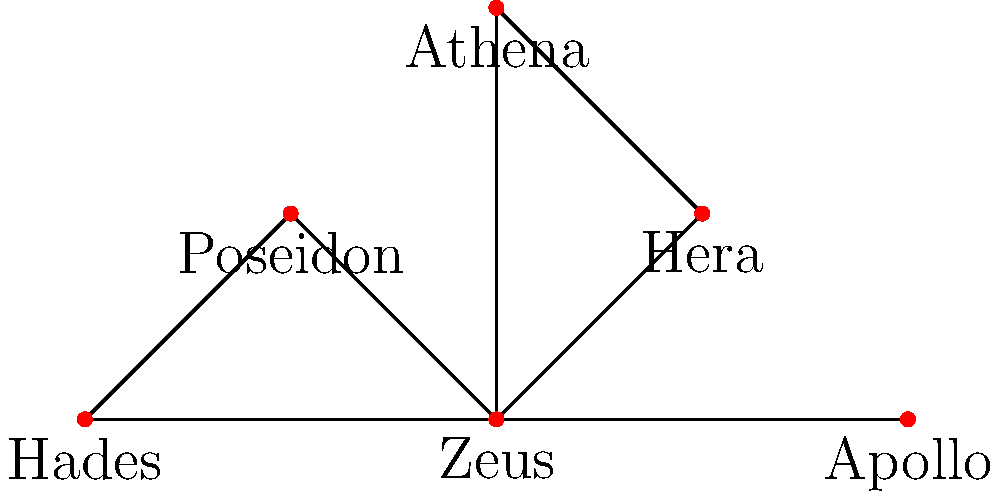In the network graph representing relationships between Greek mythological characters, which character has the highest degree centrality (i.e., the most direct connections to other characters)? To determine the character with the highest degree centrality, we need to count the number of direct connections (edges) each character has to other characters in the network graph. Let's analyze each character:

1. Zeus: Connected to Hera, Poseidon, Athena, Hades, and Apollo (5 connections)
2. Hera: Connected to Zeus and Athena (2 connections)
3. Poseidon: Connected to Zeus (1 connection)
4. Athena: Connected to Zeus and Hera (2 connections)
5. Hades: Connected to Zeus and Poseidon (2 connections)
6. Apollo: Connected to Zeus (1 connection)

By counting the number of edges connected to each vertex (character), we can see that Zeus has the highest number of connections with 5 direct links to other characters in the network.

This high degree centrality for Zeus aligns with his mythological role as the king of the gods, having numerous relationships and interactions with other deities in Greek mythology. This network structure could be used in storytelling to emphasize Zeus's central role in various myths and his influence over other characters.
Answer: Zeus 